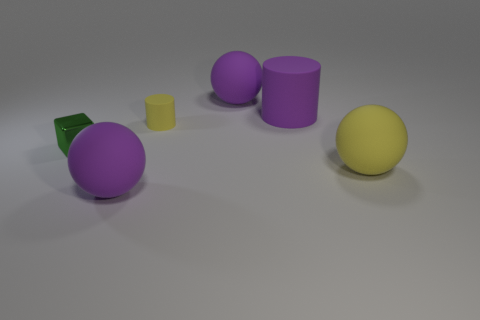Subtract all blue cubes. How many purple spheres are left? 2 Subtract all big yellow spheres. How many spheres are left? 2 Add 4 green blocks. How many objects exist? 10 Subtract all yellow balls. How many balls are left? 2 Subtract 1 cylinders. How many cylinders are left? 1 Subtract 1 purple spheres. How many objects are left? 5 Subtract all blocks. How many objects are left? 5 Subtract all brown balls. Subtract all purple blocks. How many balls are left? 3 Subtract all large yellow metallic cylinders. Subtract all green metal things. How many objects are left? 5 Add 4 purple things. How many purple things are left? 7 